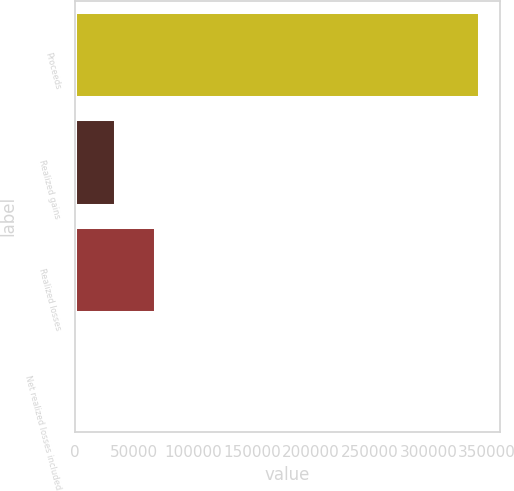Convert chart. <chart><loc_0><loc_0><loc_500><loc_500><bar_chart><fcel>Proceeds<fcel>Realized gains<fcel>Realized losses<fcel>Net realized losses included<nl><fcel>343647<fcel>34717.5<fcel>69043<fcel>392<nl></chart> 